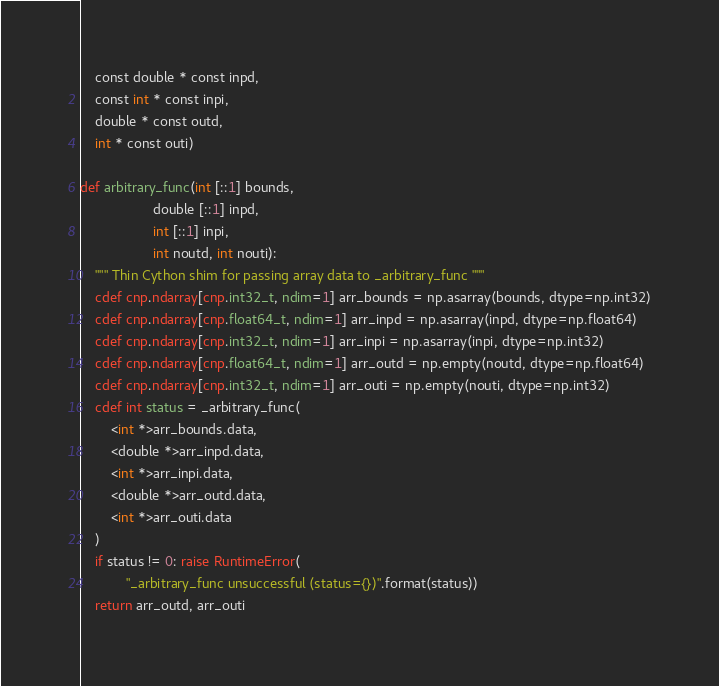Convert code to text. <code><loc_0><loc_0><loc_500><loc_500><_Cython_>    const double * const inpd,
    const int * const inpi,
    double * const outd,
    int * const outi)

def arbitrary_func(int [::1] bounds,
                   double [::1] inpd,
                   int [::1] inpi,
                   int noutd, int nouti):
    """ Thin Cython shim for passing array data to _arbitrary_func """
    cdef cnp.ndarray[cnp.int32_t, ndim=1] arr_bounds = np.asarray(bounds, dtype=np.int32)
    cdef cnp.ndarray[cnp.float64_t, ndim=1] arr_inpd = np.asarray(inpd, dtype=np.float64)
    cdef cnp.ndarray[cnp.int32_t, ndim=1] arr_inpi = np.asarray(inpi, dtype=np.int32)
    cdef cnp.ndarray[cnp.float64_t, ndim=1] arr_outd = np.empty(noutd, dtype=np.float64)
    cdef cnp.ndarray[cnp.int32_t, ndim=1] arr_outi = np.empty(nouti, dtype=np.int32)
    cdef int status = _arbitrary_func(
        <int *>arr_bounds.data,
        <double *>arr_inpd.data,
        <int *>arr_inpi.data,
        <double *>arr_outd.data,
        <int *>arr_outi.data
    )
    if status != 0: raise RuntimeError(
            "_arbitrary_func unsuccessful (status={})".format(status))
    return arr_outd, arr_outi
</code> 